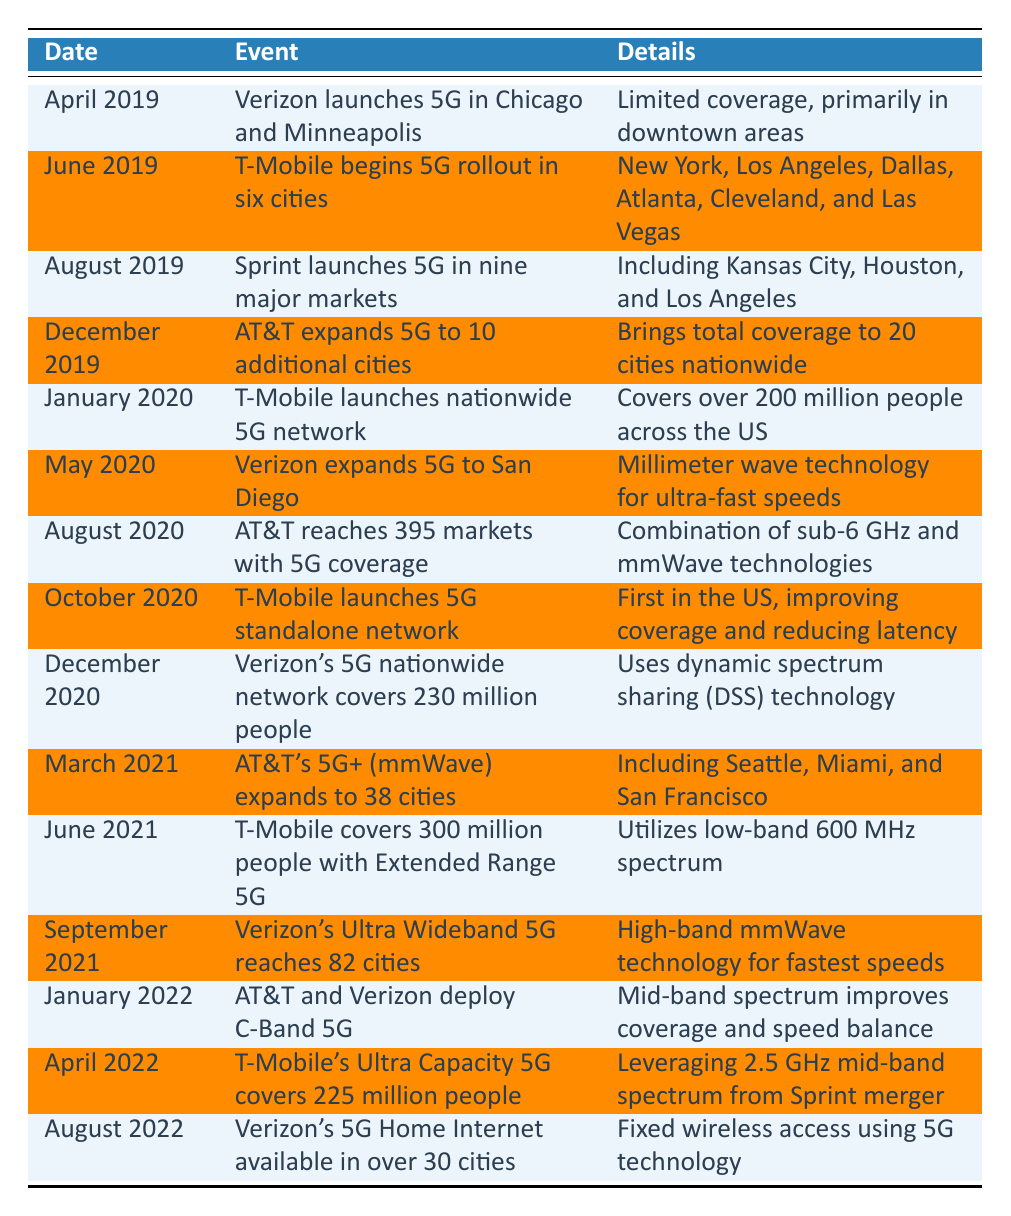What event took place in April 2019? The table indicates that in April 2019, Verizon launched 5G in Chicago and Minneapolis, with limited coverage primarily in downtown areas.
Answer: Verizon launches 5G in Chicago and Minneapolis How many cities did T-Mobile's 5G rollout cover in June 2019? According to the table, T-Mobile began its 5G rollout in June 2019 across six cities, which are explicitly listed.
Answer: Six cities True or False: Sprint launched its 5G network in Kansas City, Houston, and Los Angeles. The table verifies that Sprint launched 5G in nine major markets, mentioning Kansas City, Houston, and Los Angeles, thus confirming the statement.
Answer: True What was the significant achievement of T-Mobile in January 2020? The table shows that T-Mobile launched a nationwide 5G network in January 2020, which was significant because it covered over 200 million people across the US.
Answer: Launched nationwide 5G network How many additional cities did AT&T expand to in December 2019? The table states that in December 2019, AT&T expanded 5G to 10 additional cities, bringing its total coverage to 20 cities nationwide.
Answer: 10 additional cities Which company reached 395 markets with 5G coverage in August 2020? The evidence in the table shows that AT&T reached 395 markets with 5G coverage in August 2020, achieved through a combination of technologies.
Answer: AT&T What is the combined total of cities where T-Mobile and Verizon launched 5G by August 2022? From the table, we see that T-Mobile launched 5G in June 2019 in six cities, and Verizon launched its 5G in April 2019 covering Chicago and Minneapolis alone. By August 2022, Verizon's 5G Home Internet was available in over 30 cities. Adding these, the total is 6 + 2 + 30 = 38 cities.
Answer: 38 cities True or False: AT&T and Verizon implemented C-Band 5G in January 2021. By checking the table, we find that the implementation of C-Band 5G by AT&T and Verizon occurred in January 2022, thus the statement is incorrect.
Answer: False What was the total population coverage for T-Mobile by June 2021? The table indicates that T-Mobile covered 300 million people with Extended Range 5G by June 2021, utilizing low-band spectrum.
Answer: 300 million people 